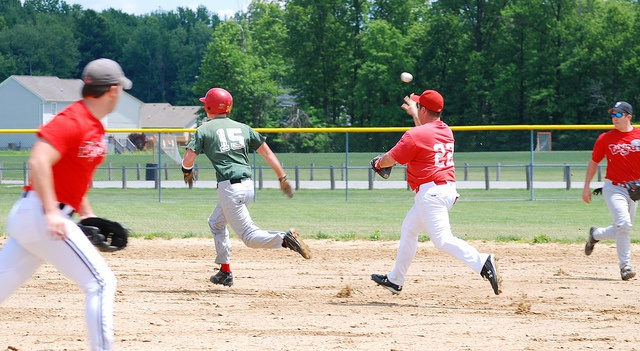Describe the objects in this image and their specific colors. I can see people in teal, lavender, red, lightpink, and salmon tones, people in teal, lavender, brown, salmon, and lightpink tones, people in teal, darkgray, lightgray, black, and gray tones, people in teal, brown, darkgray, and lavender tones, and baseball glove in teal, black, gray, and darkgray tones in this image. 